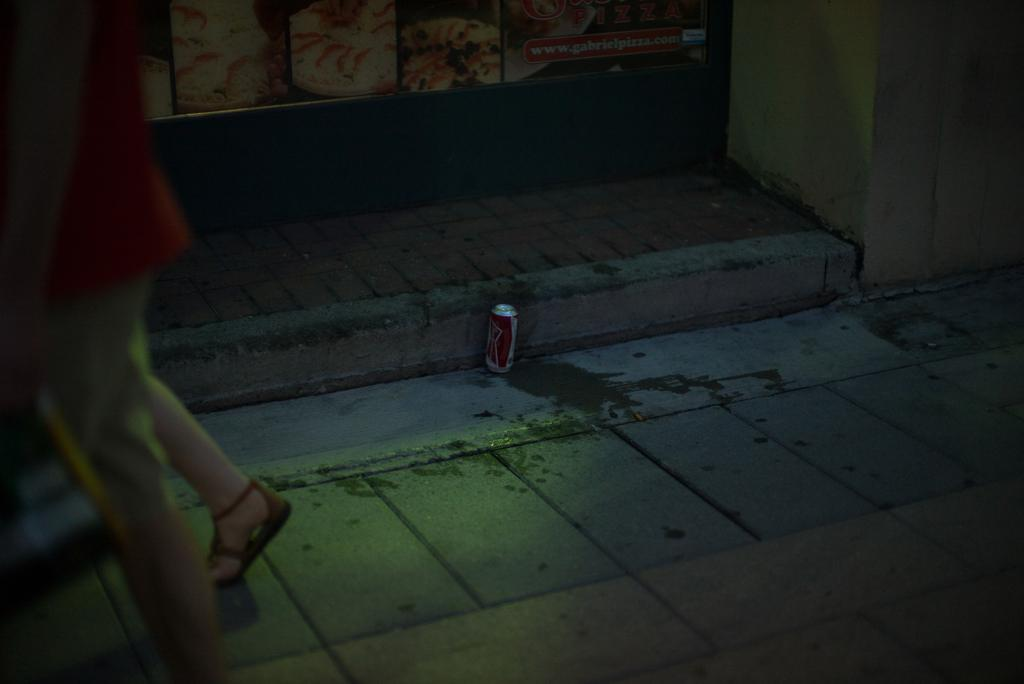What is on the floor in the image? There is a cool drink on the floor. Where is the woman located in the image? The woman is on the left side of the image. What can be seen in the background of the image? There is a wall in the background of the image. What is on the wall in the image? There is a poster on the wall. What type of birds can be seen flying in the image? There are no birds present in the image. What is the purpose of the cool drink in the image? The purpose of the cool drink cannot be determined from the image alone, as it may be for drinking or decoration. 